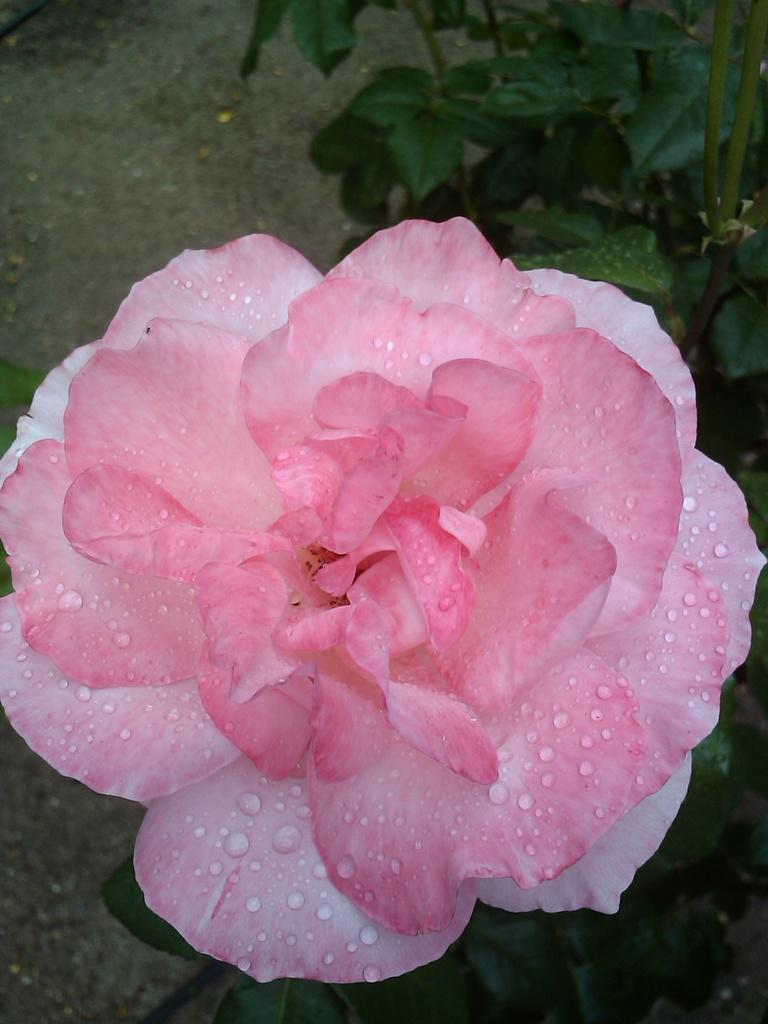What type of flower is in the image? There is a pink flower in the image. Where is the flower located? The flower is on a plant. What else can be seen on the plant besides the flower? The plant has leaves. What can be seen in the background of the image? There is land visible in the background of the image. What type of frame surrounds the flower in the image? There is no frame surrounding the flower in the image; it is a natural scene with a flower on a plant. 